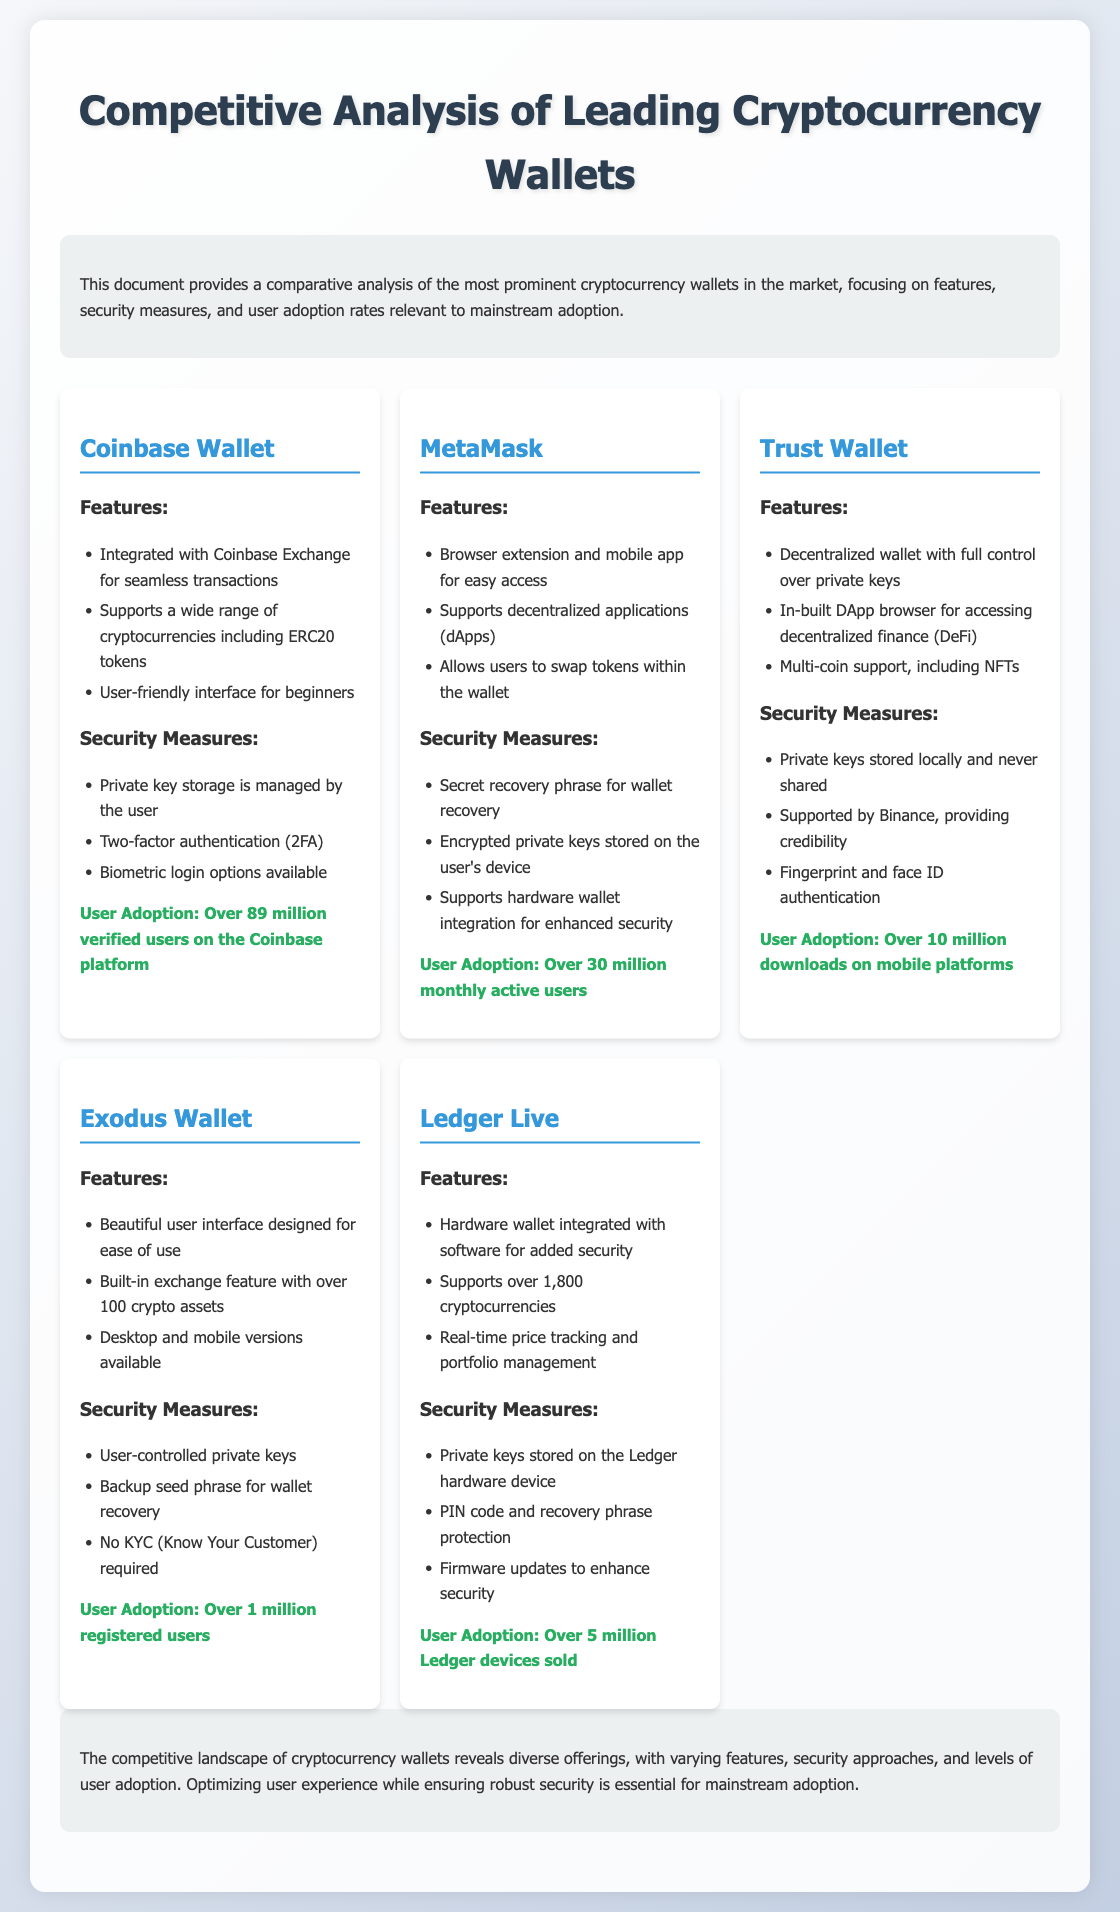What is the number of verified users on Coinbase Wallet? The document states that Coinbase Wallet has over 89 million verified users on the Coinbase platform.
Answer: Over 89 million How many monthly active users does MetaMask have? The document indicates that MetaMask has over 30 million monthly active users.
Answer: Over 30 million What unique feature does Trust Wallet offer in terms of control? Trust Wallet is a decentralized wallet that provides full control over private keys.
Answer: Full control over private keys How many cryptocurrencies does Ledger Live support? The document mentions that Ledger Live supports over 1,800 cryptocurrencies.
Answer: Over 1,800 What backup option does Exodus Wallet provide for wallet recovery? Exodus Wallet offers a backup seed phrase for wallet recovery.
Answer: Backup seed phrase Which wallet is supported by Binance? The document states that Trust Wallet is supported by Binance.
Answer: Trust Wallet What is a common security feature across the wallets analyzed? The analyzed wallets commonly implement two-factor authentication (2FA) as a security measure.
Answer: Two-factor authentication How does Exodus Wallet handle user privacy? The document specifies that Exodus Wallet does not require KYC (Know Your Customer).
Answer: No KYC required Which wallet allows users to swap tokens within the wallet? The document indicates that MetaMask allows users to swap tokens within the wallet.
Answer: MetaMask 